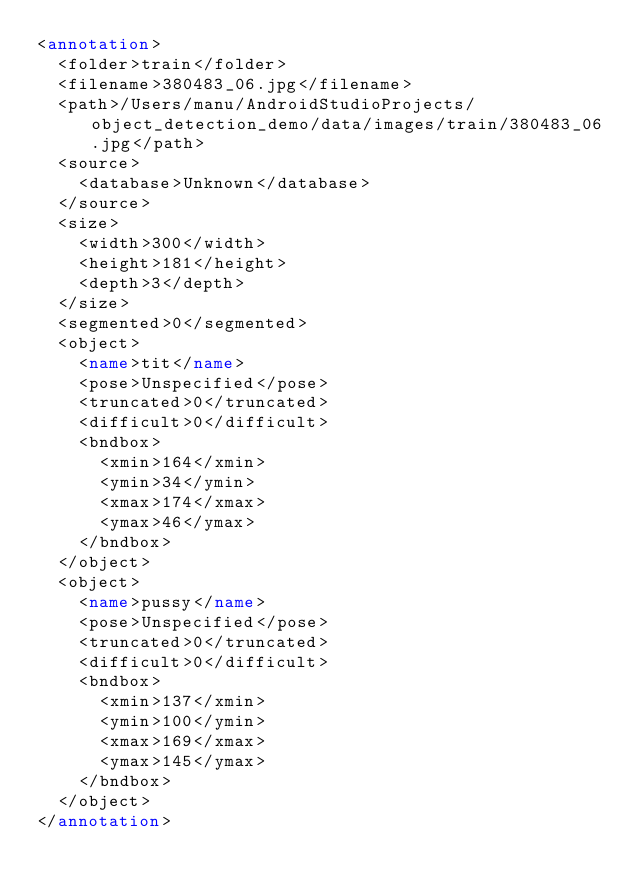<code> <loc_0><loc_0><loc_500><loc_500><_XML_><annotation>
	<folder>train</folder>
	<filename>380483_06.jpg</filename>
	<path>/Users/manu/AndroidStudioProjects/object_detection_demo/data/images/train/380483_06.jpg</path>
	<source>
		<database>Unknown</database>
	</source>
	<size>
		<width>300</width>
		<height>181</height>
		<depth>3</depth>
	</size>
	<segmented>0</segmented>
	<object>
		<name>tit</name>
		<pose>Unspecified</pose>
		<truncated>0</truncated>
		<difficult>0</difficult>
		<bndbox>
			<xmin>164</xmin>
			<ymin>34</ymin>
			<xmax>174</xmax>
			<ymax>46</ymax>
		</bndbox>
	</object>
	<object>
		<name>pussy</name>
		<pose>Unspecified</pose>
		<truncated>0</truncated>
		<difficult>0</difficult>
		<bndbox>
			<xmin>137</xmin>
			<ymin>100</ymin>
			<xmax>169</xmax>
			<ymax>145</ymax>
		</bndbox>
	</object>
</annotation>
</code> 